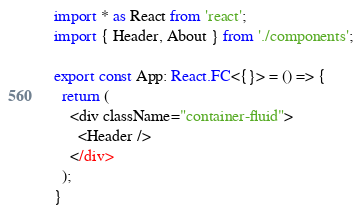Convert code to text. <code><loc_0><loc_0><loc_500><loc_500><_TypeScript_>import * as React from 'react';
import { Header, About } from './components';

export const App: React.FC<{}> = () => {
  return (
    <div className="container-fluid">
      <Header />
    </div>
  );
}
</code> 